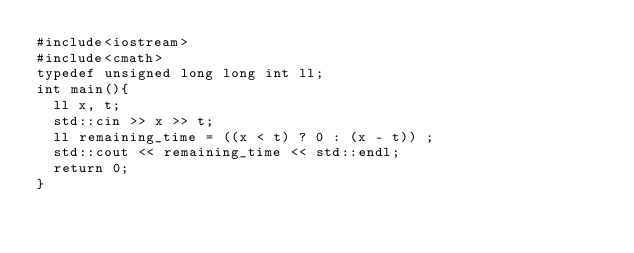Convert code to text. <code><loc_0><loc_0><loc_500><loc_500><_C++_>#include<iostream>
#include<cmath>
typedef unsigned long long int ll;
int main(){
  ll x, t;
  std::cin >> x >> t;
  ll remaining_time = ((x < t) ? 0 : (x - t)) ;
  std::cout << remaining_time << std::endl;
  return 0;
}</code> 